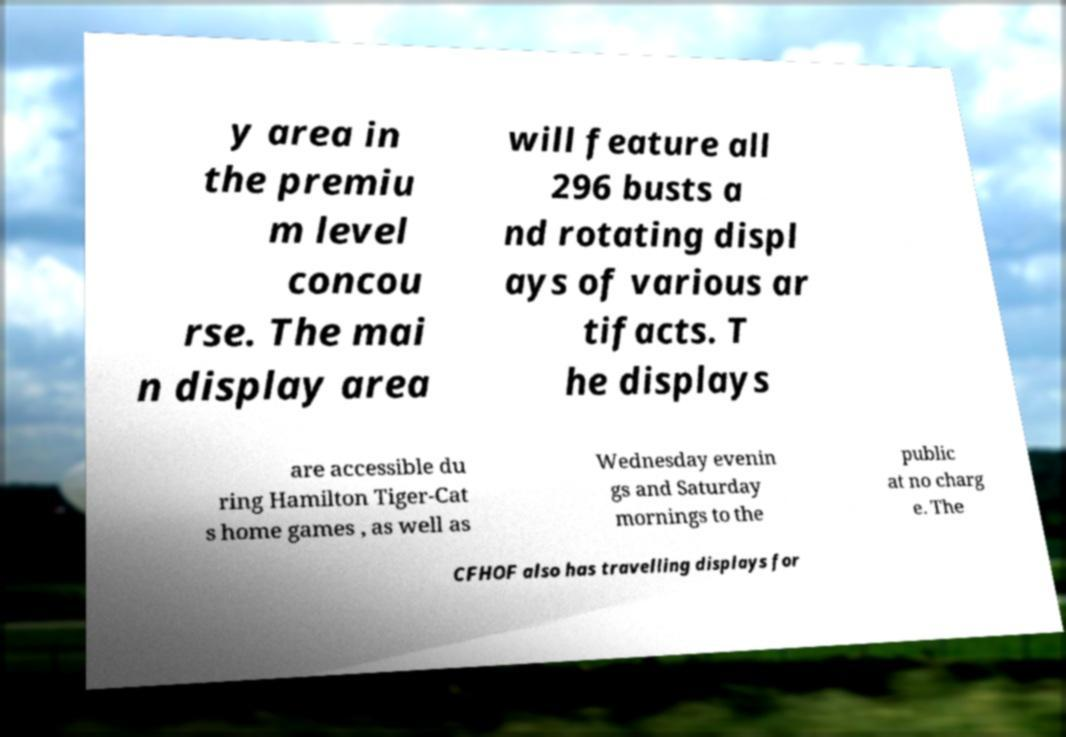Please identify and transcribe the text found in this image. y area in the premiu m level concou rse. The mai n display area will feature all 296 busts a nd rotating displ ays of various ar tifacts. T he displays are accessible du ring Hamilton Tiger-Cat s home games , as well as Wednesday evenin gs and Saturday mornings to the public at no charg e. The CFHOF also has travelling displays for 